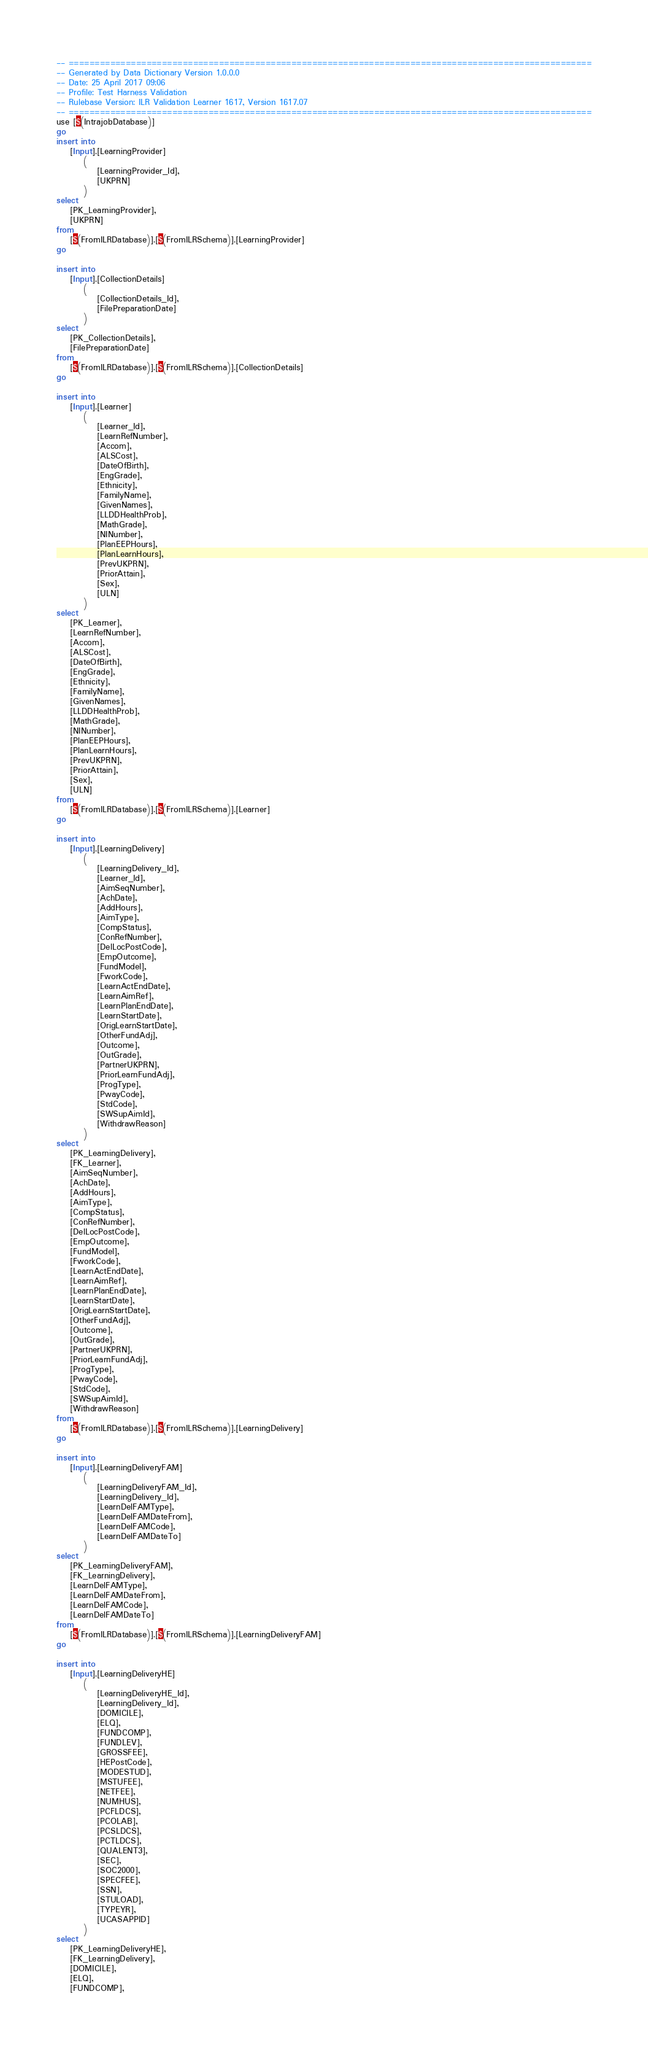Convert code to text. <code><loc_0><loc_0><loc_500><loc_500><_SQL_>-- =====================================================================================================
-- Generated by Data Dictionary Version 1.0.0.0
-- Date: 25 April 2017 09:06
-- Profile: Test Harness Validation
-- Rulebase Version: ILR Validation Learner 1617, Version 1617.07
-- =====================================================================================================
use [$(IntrajobDatabase)]
go
insert into
	[Input].[LearningProvider]
		(
			[LearningProvider_Id],
			[UKPRN]
		)
select
	[PK_LearningProvider],
	[UKPRN]
from
	[$(FromILRDatabase)].[$(FromILRSchema)].[LearningProvider]
go

insert into
	[Input].[CollectionDetails]
		(
			[CollectionDetails_Id],
			[FilePreparationDate]
		)
select
	[PK_CollectionDetails],
	[FilePreparationDate]
from
	[$(FromILRDatabase)].[$(FromILRSchema)].[CollectionDetails]
go

insert into
	[Input].[Learner]
		(
			[Learner_Id],
			[LearnRefNumber],
			[Accom],
			[ALSCost],
			[DateOfBirth],
			[EngGrade],
			[Ethnicity],
			[FamilyName],
			[GivenNames],
			[LLDDHealthProb],
			[MathGrade],
			[NINumber],
			[PlanEEPHours],
			[PlanLearnHours],
			[PrevUKPRN],
			[PriorAttain],
			[Sex],
			[ULN]
		)
select
	[PK_Learner],
	[LearnRefNumber],
	[Accom],
	[ALSCost],
	[DateOfBirth],
	[EngGrade],
	[Ethnicity],
	[FamilyName],
	[GivenNames],
	[LLDDHealthProb],
	[MathGrade],
	[NINumber],
	[PlanEEPHours],
	[PlanLearnHours],
	[PrevUKPRN],
	[PriorAttain],
	[Sex],
	[ULN]
from
	[$(FromILRDatabase)].[$(FromILRSchema)].[Learner]
go

insert into
	[Input].[LearningDelivery]
		(
			[LearningDelivery_Id],
			[Learner_Id],
			[AimSeqNumber],
			[AchDate],
			[AddHours],
			[AimType],
			[CompStatus],
			[ConRefNumber],
			[DelLocPostCode],
			[EmpOutcome],
			[FundModel],
			[FworkCode],
			[LearnActEndDate],
			[LearnAimRef],
			[LearnPlanEndDate],
			[LearnStartDate],
			[OrigLearnStartDate],
			[OtherFundAdj],
			[Outcome],
			[OutGrade],
			[PartnerUKPRN],
			[PriorLearnFundAdj],
			[ProgType],
			[PwayCode],
			[StdCode],
			[SWSupAimId],
			[WithdrawReason]
		)
select
	[PK_LearningDelivery],
	[FK_Learner],
	[AimSeqNumber],
	[AchDate],
	[AddHours],
	[AimType],
	[CompStatus],
	[ConRefNumber],
	[DelLocPostCode],
	[EmpOutcome],
	[FundModel],
	[FworkCode],
	[LearnActEndDate],
	[LearnAimRef],
	[LearnPlanEndDate],
	[LearnStartDate],
	[OrigLearnStartDate],
	[OtherFundAdj],
	[Outcome],
	[OutGrade],
	[PartnerUKPRN],
	[PriorLearnFundAdj],
	[ProgType],
	[PwayCode],
	[StdCode],
	[SWSupAimId],
	[WithdrawReason]
from
	[$(FromILRDatabase)].[$(FromILRSchema)].[LearningDelivery]
go

insert into
	[Input].[LearningDeliveryFAM]
		(
			[LearningDeliveryFAM_Id],
			[LearningDelivery_Id],
			[LearnDelFAMType],
			[LearnDelFAMDateFrom],
			[LearnDelFAMCode],
			[LearnDelFAMDateTo]
		)
select
	[PK_LearningDeliveryFAM],
	[FK_LearningDelivery],
	[LearnDelFAMType],
	[LearnDelFAMDateFrom],
	[LearnDelFAMCode],
	[LearnDelFAMDateTo]
from
	[$(FromILRDatabase)].[$(FromILRSchema)].[LearningDeliveryFAM]
go

insert into
	[Input].[LearningDeliveryHE]
		(
			[LearningDeliveryHE_Id],
			[LearningDelivery_Id],
			[DOMICILE],
			[ELQ],
			[FUNDCOMP],
			[FUNDLEV],
			[GROSSFEE],
			[HEPostCode],
			[MODESTUD],
			[MSTUFEE],
			[NETFEE],
			[NUMHUS],
			[PCFLDCS],
			[PCOLAB],
			[PCSLDCS],
			[PCTLDCS],
			[QUALENT3],
			[SEC],
			[SOC2000],
			[SPECFEE],
			[SSN],
			[STULOAD],
			[TYPEYR],
			[UCASAPPID]
		)
select
	[PK_LearningDeliveryHE],
	[FK_LearningDelivery],
	[DOMICILE],
	[ELQ],
	[FUNDCOMP],</code> 